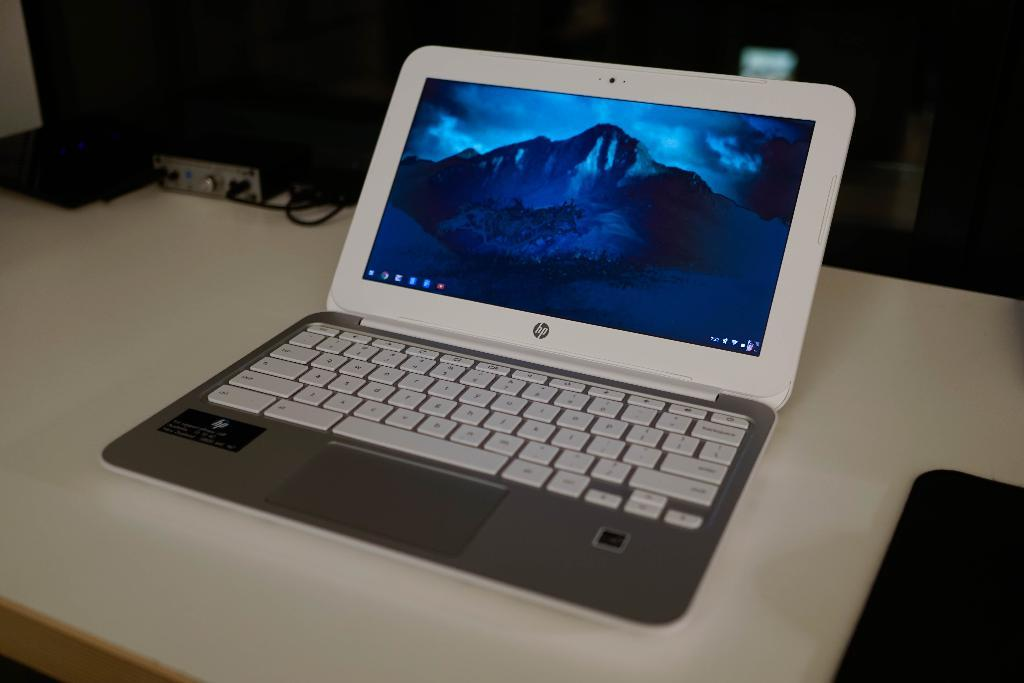<image>
Share a concise interpretation of the image provided. An hp brand laptop has a mountain as the background screen image. 